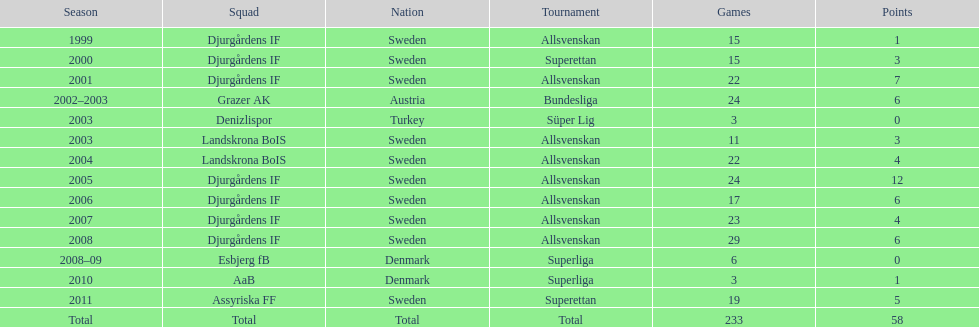What was the number of goals he scored in 2005? 12. 